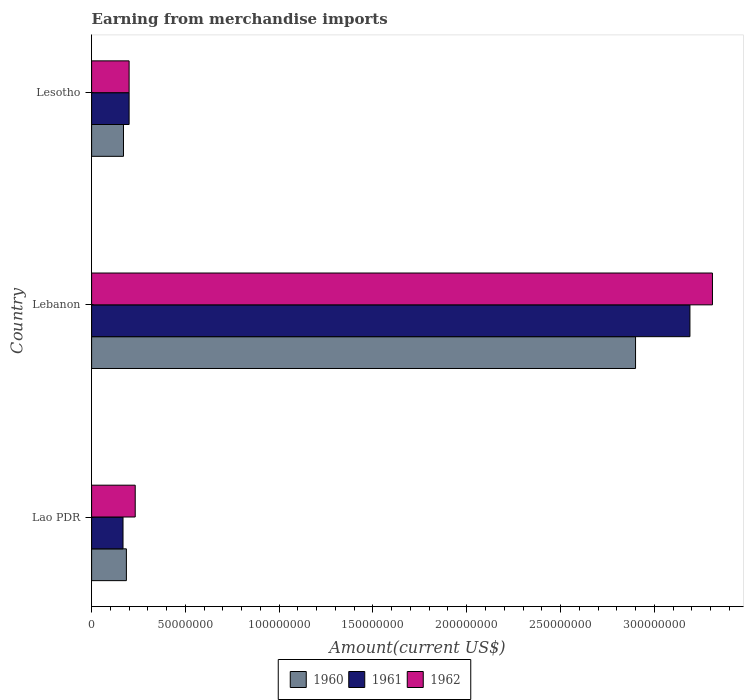Are the number of bars on each tick of the Y-axis equal?
Provide a short and direct response. Yes. What is the label of the 1st group of bars from the top?
Your response must be concise. Lesotho. In how many cases, is the number of bars for a given country not equal to the number of legend labels?
Your answer should be compact. 0. What is the amount earned from merchandise imports in 1960 in Lesotho?
Provide a short and direct response. 1.70e+07. Across all countries, what is the maximum amount earned from merchandise imports in 1962?
Offer a terse response. 3.31e+08. In which country was the amount earned from merchandise imports in 1960 maximum?
Make the answer very short. Lebanon. In which country was the amount earned from merchandise imports in 1962 minimum?
Make the answer very short. Lesotho. What is the total amount earned from merchandise imports in 1962 in the graph?
Offer a very short reply. 3.74e+08. What is the difference between the amount earned from merchandise imports in 1962 in Lebanon and that in Lesotho?
Provide a succinct answer. 3.11e+08. What is the difference between the amount earned from merchandise imports in 1962 in Lao PDR and the amount earned from merchandise imports in 1961 in Lesotho?
Offer a terse response. 3.25e+06. What is the average amount earned from merchandise imports in 1960 per country?
Keep it short and to the point. 1.09e+08. What is the ratio of the amount earned from merchandise imports in 1962 in Lao PDR to that in Lebanon?
Provide a short and direct response. 0.07. What is the difference between the highest and the second highest amount earned from merchandise imports in 1961?
Keep it short and to the point. 2.99e+08. What is the difference between the highest and the lowest amount earned from merchandise imports in 1961?
Give a very brief answer. 3.02e+08. Is it the case that in every country, the sum of the amount earned from merchandise imports in 1960 and amount earned from merchandise imports in 1961 is greater than the amount earned from merchandise imports in 1962?
Your response must be concise. Yes. How many bars are there?
Offer a terse response. 9. Are all the bars in the graph horizontal?
Keep it short and to the point. Yes. How many countries are there in the graph?
Offer a terse response. 3. Does the graph contain grids?
Keep it short and to the point. No. What is the title of the graph?
Make the answer very short. Earning from merchandise imports. What is the label or title of the X-axis?
Your response must be concise. Amount(current US$). What is the label or title of the Y-axis?
Your answer should be very brief. Country. What is the Amount(current US$) of 1960 in Lao PDR?
Your answer should be compact. 1.86e+07. What is the Amount(current US$) in 1961 in Lao PDR?
Offer a terse response. 1.68e+07. What is the Amount(current US$) of 1962 in Lao PDR?
Your answer should be very brief. 2.32e+07. What is the Amount(current US$) in 1960 in Lebanon?
Your answer should be very brief. 2.90e+08. What is the Amount(current US$) of 1961 in Lebanon?
Keep it short and to the point. 3.19e+08. What is the Amount(current US$) in 1962 in Lebanon?
Provide a succinct answer. 3.31e+08. What is the Amount(current US$) of 1960 in Lesotho?
Your response must be concise. 1.70e+07. What is the Amount(current US$) in 1962 in Lesotho?
Provide a succinct answer. 2.00e+07. Across all countries, what is the maximum Amount(current US$) of 1960?
Ensure brevity in your answer.  2.90e+08. Across all countries, what is the maximum Amount(current US$) in 1961?
Offer a terse response. 3.19e+08. Across all countries, what is the maximum Amount(current US$) in 1962?
Make the answer very short. 3.31e+08. Across all countries, what is the minimum Amount(current US$) of 1960?
Your answer should be very brief. 1.70e+07. Across all countries, what is the minimum Amount(current US$) in 1961?
Offer a very short reply. 1.68e+07. What is the total Amount(current US$) of 1960 in the graph?
Your answer should be very brief. 3.26e+08. What is the total Amount(current US$) of 1961 in the graph?
Your response must be concise. 3.56e+08. What is the total Amount(current US$) in 1962 in the graph?
Your response must be concise. 3.74e+08. What is the difference between the Amount(current US$) in 1960 in Lao PDR and that in Lebanon?
Your answer should be compact. -2.71e+08. What is the difference between the Amount(current US$) of 1961 in Lao PDR and that in Lebanon?
Offer a terse response. -3.02e+08. What is the difference between the Amount(current US$) in 1962 in Lao PDR and that in Lebanon?
Your response must be concise. -3.08e+08. What is the difference between the Amount(current US$) of 1960 in Lao PDR and that in Lesotho?
Keep it short and to the point. 1.55e+06. What is the difference between the Amount(current US$) in 1961 in Lao PDR and that in Lesotho?
Make the answer very short. -3.25e+06. What is the difference between the Amount(current US$) in 1962 in Lao PDR and that in Lesotho?
Offer a very short reply. 3.25e+06. What is the difference between the Amount(current US$) in 1960 in Lebanon and that in Lesotho?
Your response must be concise. 2.73e+08. What is the difference between the Amount(current US$) in 1961 in Lebanon and that in Lesotho?
Keep it short and to the point. 2.99e+08. What is the difference between the Amount(current US$) of 1962 in Lebanon and that in Lesotho?
Keep it short and to the point. 3.11e+08. What is the difference between the Amount(current US$) in 1960 in Lao PDR and the Amount(current US$) in 1961 in Lebanon?
Your answer should be very brief. -3.00e+08. What is the difference between the Amount(current US$) in 1960 in Lao PDR and the Amount(current US$) in 1962 in Lebanon?
Your response must be concise. -3.12e+08. What is the difference between the Amount(current US$) of 1961 in Lao PDR and the Amount(current US$) of 1962 in Lebanon?
Provide a succinct answer. -3.14e+08. What is the difference between the Amount(current US$) of 1960 in Lao PDR and the Amount(current US$) of 1961 in Lesotho?
Your answer should be compact. -1.45e+06. What is the difference between the Amount(current US$) in 1960 in Lao PDR and the Amount(current US$) in 1962 in Lesotho?
Your response must be concise. -1.45e+06. What is the difference between the Amount(current US$) of 1961 in Lao PDR and the Amount(current US$) of 1962 in Lesotho?
Make the answer very short. -3.25e+06. What is the difference between the Amount(current US$) in 1960 in Lebanon and the Amount(current US$) in 1961 in Lesotho?
Offer a very short reply. 2.70e+08. What is the difference between the Amount(current US$) of 1960 in Lebanon and the Amount(current US$) of 1962 in Lesotho?
Offer a terse response. 2.70e+08. What is the difference between the Amount(current US$) in 1961 in Lebanon and the Amount(current US$) in 1962 in Lesotho?
Your answer should be compact. 2.99e+08. What is the average Amount(current US$) in 1960 per country?
Make the answer very short. 1.09e+08. What is the average Amount(current US$) in 1961 per country?
Give a very brief answer. 1.19e+08. What is the average Amount(current US$) of 1962 per country?
Provide a succinct answer. 1.25e+08. What is the difference between the Amount(current US$) of 1960 and Amount(current US$) of 1961 in Lao PDR?
Make the answer very short. 1.80e+06. What is the difference between the Amount(current US$) in 1960 and Amount(current US$) in 1962 in Lao PDR?
Your answer should be compact. -4.70e+06. What is the difference between the Amount(current US$) in 1961 and Amount(current US$) in 1962 in Lao PDR?
Your response must be concise. -6.50e+06. What is the difference between the Amount(current US$) in 1960 and Amount(current US$) in 1961 in Lebanon?
Keep it short and to the point. -2.90e+07. What is the difference between the Amount(current US$) in 1960 and Amount(current US$) in 1962 in Lebanon?
Provide a succinct answer. -4.10e+07. What is the difference between the Amount(current US$) in 1961 and Amount(current US$) in 1962 in Lebanon?
Provide a succinct answer. -1.20e+07. What is the difference between the Amount(current US$) of 1961 and Amount(current US$) of 1962 in Lesotho?
Your response must be concise. 0. What is the ratio of the Amount(current US$) in 1960 in Lao PDR to that in Lebanon?
Provide a succinct answer. 0.06. What is the ratio of the Amount(current US$) in 1961 in Lao PDR to that in Lebanon?
Your answer should be compact. 0.05. What is the ratio of the Amount(current US$) of 1962 in Lao PDR to that in Lebanon?
Offer a very short reply. 0.07. What is the ratio of the Amount(current US$) of 1960 in Lao PDR to that in Lesotho?
Provide a succinct answer. 1.09. What is the ratio of the Amount(current US$) of 1961 in Lao PDR to that in Lesotho?
Your answer should be compact. 0.84. What is the ratio of the Amount(current US$) in 1962 in Lao PDR to that in Lesotho?
Provide a succinct answer. 1.16. What is the ratio of the Amount(current US$) of 1960 in Lebanon to that in Lesotho?
Your answer should be compact. 17.06. What is the ratio of the Amount(current US$) of 1961 in Lebanon to that in Lesotho?
Make the answer very short. 15.95. What is the ratio of the Amount(current US$) in 1962 in Lebanon to that in Lesotho?
Your answer should be very brief. 16.55. What is the difference between the highest and the second highest Amount(current US$) in 1960?
Offer a terse response. 2.71e+08. What is the difference between the highest and the second highest Amount(current US$) of 1961?
Give a very brief answer. 2.99e+08. What is the difference between the highest and the second highest Amount(current US$) in 1962?
Your answer should be compact. 3.08e+08. What is the difference between the highest and the lowest Amount(current US$) of 1960?
Provide a short and direct response. 2.73e+08. What is the difference between the highest and the lowest Amount(current US$) in 1961?
Provide a succinct answer. 3.02e+08. What is the difference between the highest and the lowest Amount(current US$) of 1962?
Provide a succinct answer. 3.11e+08. 